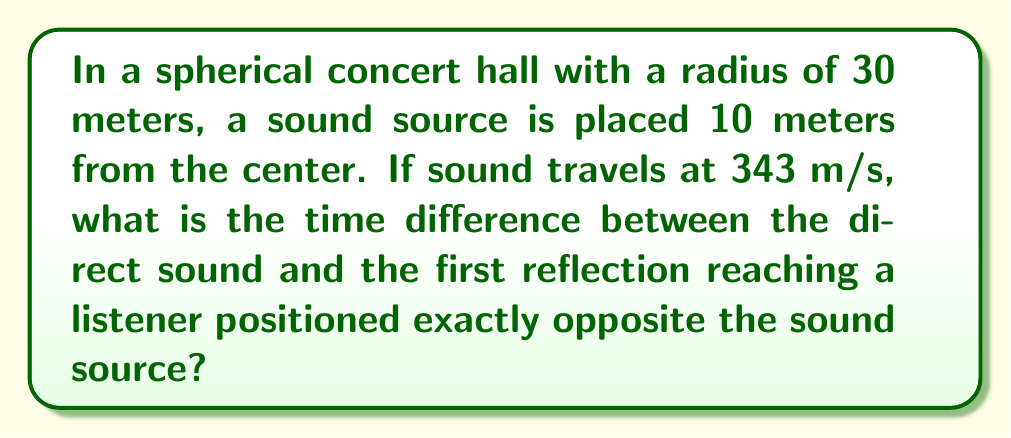What is the answer to this math problem? Let's approach this step-by-step:

1) First, we need to understand the geometry of the situation. We have a sphere with radius $R = 30$ m. The sound source is 10 m from the center, and the listener is on the opposite side.

2) The direct path of the sound is a straight line through the center of the sphere. Its length is the diameter of the sphere minus the distance of the sound source from the center:

   $d_{direct} = 2R - 10 = 60 - 10 = 50$ m

3) The reflected path consists of two parts: from the source to the nearest point on the sphere's surface, and from there to the listener. Due to the symmetry of the sphere, these two parts are equal.

4) To find the length of each part, we can use the Pythagorean theorem in the right triangle formed by the center of the sphere, the sound source, and the point of reflection:

   $$(30)^2 = (10)^2 + x^2$$
   
   $$900 = 100 + x^2$$
   
   $$x^2 = 800$$
   
   $$x = \sqrt{800} = 20\sqrt{2}$$ m

5) The total length of the reflected path is thus:

   $d_{reflected} = 2(20\sqrt{2}) = 40\sqrt{2}$ m

6) Now we can calculate the time for each path:

   $t_{direct} = \frac{50}{343} \approx 0.1458$ s
   
   $t_{reflected} = \frac{40\sqrt{2}}{343} \approx 0.1647$ s

7) The time difference is:

   $\Delta t = t_{reflected} - t_{direct} \approx 0.1647 - 0.1458 = 0.0189$ s
Answer: $0.0189$ s 